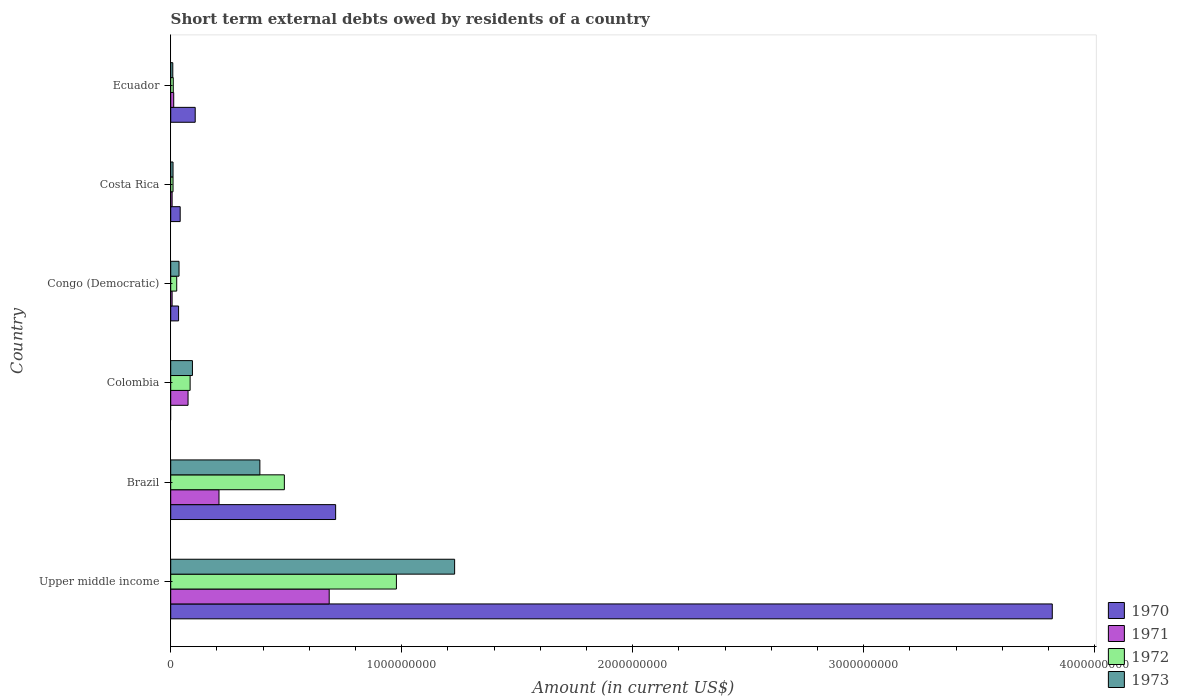How many different coloured bars are there?
Your answer should be very brief. 4. How many groups of bars are there?
Your response must be concise. 6. Are the number of bars on each tick of the Y-axis equal?
Your answer should be compact. No. How many bars are there on the 6th tick from the top?
Ensure brevity in your answer.  4. How many bars are there on the 1st tick from the bottom?
Your answer should be compact. 4. In how many cases, is the number of bars for a given country not equal to the number of legend labels?
Keep it short and to the point. 1. What is the amount of short-term external debts owed by residents in 1970 in Brazil?
Give a very brief answer. 7.14e+08. Across all countries, what is the maximum amount of short-term external debts owed by residents in 1972?
Give a very brief answer. 9.77e+08. In which country was the amount of short-term external debts owed by residents in 1972 maximum?
Make the answer very short. Upper middle income. What is the total amount of short-term external debts owed by residents in 1972 in the graph?
Make the answer very short. 1.60e+09. What is the difference between the amount of short-term external debts owed by residents in 1973 in Brazil and that in Ecuador?
Offer a very short reply. 3.77e+08. What is the difference between the amount of short-term external debts owed by residents in 1972 in Congo (Democratic) and the amount of short-term external debts owed by residents in 1971 in Brazil?
Offer a terse response. -1.83e+08. What is the average amount of short-term external debts owed by residents in 1970 per country?
Provide a short and direct response. 7.85e+08. What is the difference between the amount of short-term external debts owed by residents in 1970 and amount of short-term external debts owed by residents in 1971 in Brazil?
Your answer should be very brief. 5.05e+08. In how many countries, is the amount of short-term external debts owed by residents in 1972 greater than 1800000000 US$?
Give a very brief answer. 0. What is the ratio of the amount of short-term external debts owed by residents in 1972 in Brazil to that in Colombia?
Your response must be concise. 5.86. Is the difference between the amount of short-term external debts owed by residents in 1970 in Brazil and Upper middle income greater than the difference between the amount of short-term external debts owed by residents in 1971 in Brazil and Upper middle income?
Your answer should be very brief. No. What is the difference between the highest and the second highest amount of short-term external debts owed by residents in 1973?
Offer a very short reply. 8.43e+08. What is the difference between the highest and the lowest amount of short-term external debts owed by residents in 1973?
Offer a very short reply. 1.22e+09. Is the sum of the amount of short-term external debts owed by residents in 1973 in Congo (Democratic) and Costa Rica greater than the maximum amount of short-term external debts owed by residents in 1971 across all countries?
Provide a short and direct response. No. Are all the bars in the graph horizontal?
Provide a short and direct response. Yes. How many countries are there in the graph?
Offer a terse response. 6. What is the difference between two consecutive major ticks on the X-axis?
Offer a very short reply. 1.00e+09. Does the graph contain grids?
Offer a terse response. No. Where does the legend appear in the graph?
Provide a short and direct response. Bottom right. What is the title of the graph?
Offer a terse response. Short term external debts owed by residents of a country. What is the label or title of the X-axis?
Give a very brief answer. Amount (in current US$). What is the Amount (in current US$) of 1970 in Upper middle income?
Offer a very short reply. 3.82e+09. What is the Amount (in current US$) in 1971 in Upper middle income?
Your answer should be very brief. 6.86e+08. What is the Amount (in current US$) of 1972 in Upper middle income?
Make the answer very short. 9.77e+08. What is the Amount (in current US$) of 1973 in Upper middle income?
Provide a succinct answer. 1.23e+09. What is the Amount (in current US$) of 1970 in Brazil?
Your answer should be very brief. 7.14e+08. What is the Amount (in current US$) of 1971 in Brazil?
Provide a short and direct response. 2.09e+08. What is the Amount (in current US$) in 1972 in Brazil?
Keep it short and to the point. 4.92e+08. What is the Amount (in current US$) in 1973 in Brazil?
Provide a succinct answer. 3.86e+08. What is the Amount (in current US$) of 1971 in Colombia?
Your answer should be very brief. 7.50e+07. What is the Amount (in current US$) in 1972 in Colombia?
Make the answer very short. 8.40e+07. What is the Amount (in current US$) in 1973 in Colombia?
Your response must be concise. 9.40e+07. What is the Amount (in current US$) in 1970 in Congo (Democratic)?
Provide a short and direct response. 3.40e+07. What is the Amount (in current US$) in 1971 in Congo (Democratic)?
Provide a succinct answer. 6.00e+06. What is the Amount (in current US$) of 1972 in Congo (Democratic)?
Make the answer very short. 2.60e+07. What is the Amount (in current US$) in 1973 in Congo (Democratic)?
Provide a short and direct response. 3.60e+07. What is the Amount (in current US$) in 1970 in Costa Rica?
Offer a terse response. 4.10e+07. What is the Amount (in current US$) of 1971 in Costa Rica?
Ensure brevity in your answer.  6.00e+06. What is the Amount (in current US$) of 1973 in Costa Rica?
Ensure brevity in your answer.  1.00e+07. What is the Amount (in current US$) in 1970 in Ecuador?
Provide a succinct answer. 1.06e+08. What is the Amount (in current US$) in 1971 in Ecuador?
Provide a short and direct response. 1.30e+07. What is the Amount (in current US$) of 1972 in Ecuador?
Give a very brief answer. 1.10e+07. What is the Amount (in current US$) in 1973 in Ecuador?
Ensure brevity in your answer.  9.00e+06. Across all countries, what is the maximum Amount (in current US$) in 1970?
Offer a terse response. 3.82e+09. Across all countries, what is the maximum Amount (in current US$) of 1971?
Offer a terse response. 6.86e+08. Across all countries, what is the maximum Amount (in current US$) in 1972?
Provide a succinct answer. 9.77e+08. Across all countries, what is the maximum Amount (in current US$) of 1973?
Ensure brevity in your answer.  1.23e+09. Across all countries, what is the minimum Amount (in current US$) of 1970?
Offer a very short reply. 0. Across all countries, what is the minimum Amount (in current US$) in 1973?
Keep it short and to the point. 9.00e+06. What is the total Amount (in current US$) in 1970 in the graph?
Ensure brevity in your answer.  4.71e+09. What is the total Amount (in current US$) of 1971 in the graph?
Provide a succinct answer. 9.95e+08. What is the total Amount (in current US$) in 1972 in the graph?
Make the answer very short. 1.60e+09. What is the total Amount (in current US$) in 1973 in the graph?
Give a very brief answer. 1.76e+09. What is the difference between the Amount (in current US$) of 1970 in Upper middle income and that in Brazil?
Your answer should be very brief. 3.10e+09. What is the difference between the Amount (in current US$) of 1971 in Upper middle income and that in Brazil?
Give a very brief answer. 4.77e+08. What is the difference between the Amount (in current US$) in 1972 in Upper middle income and that in Brazil?
Make the answer very short. 4.85e+08. What is the difference between the Amount (in current US$) of 1973 in Upper middle income and that in Brazil?
Provide a succinct answer. 8.43e+08. What is the difference between the Amount (in current US$) in 1971 in Upper middle income and that in Colombia?
Ensure brevity in your answer.  6.11e+08. What is the difference between the Amount (in current US$) of 1972 in Upper middle income and that in Colombia?
Make the answer very short. 8.93e+08. What is the difference between the Amount (in current US$) in 1973 in Upper middle income and that in Colombia?
Make the answer very short. 1.14e+09. What is the difference between the Amount (in current US$) of 1970 in Upper middle income and that in Congo (Democratic)?
Give a very brief answer. 3.78e+09. What is the difference between the Amount (in current US$) of 1971 in Upper middle income and that in Congo (Democratic)?
Give a very brief answer. 6.80e+08. What is the difference between the Amount (in current US$) in 1972 in Upper middle income and that in Congo (Democratic)?
Provide a succinct answer. 9.51e+08. What is the difference between the Amount (in current US$) of 1973 in Upper middle income and that in Congo (Democratic)?
Give a very brief answer. 1.19e+09. What is the difference between the Amount (in current US$) in 1970 in Upper middle income and that in Costa Rica?
Offer a very short reply. 3.78e+09. What is the difference between the Amount (in current US$) of 1971 in Upper middle income and that in Costa Rica?
Offer a terse response. 6.80e+08. What is the difference between the Amount (in current US$) in 1972 in Upper middle income and that in Costa Rica?
Ensure brevity in your answer.  9.67e+08. What is the difference between the Amount (in current US$) in 1973 in Upper middle income and that in Costa Rica?
Ensure brevity in your answer.  1.22e+09. What is the difference between the Amount (in current US$) in 1970 in Upper middle income and that in Ecuador?
Your answer should be very brief. 3.71e+09. What is the difference between the Amount (in current US$) of 1971 in Upper middle income and that in Ecuador?
Provide a short and direct response. 6.73e+08. What is the difference between the Amount (in current US$) of 1972 in Upper middle income and that in Ecuador?
Give a very brief answer. 9.66e+08. What is the difference between the Amount (in current US$) in 1973 in Upper middle income and that in Ecuador?
Keep it short and to the point. 1.22e+09. What is the difference between the Amount (in current US$) of 1971 in Brazil and that in Colombia?
Provide a short and direct response. 1.34e+08. What is the difference between the Amount (in current US$) in 1972 in Brazil and that in Colombia?
Your answer should be very brief. 4.08e+08. What is the difference between the Amount (in current US$) in 1973 in Brazil and that in Colombia?
Give a very brief answer. 2.92e+08. What is the difference between the Amount (in current US$) of 1970 in Brazil and that in Congo (Democratic)?
Keep it short and to the point. 6.80e+08. What is the difference between the Amount (in current US$) in 1971 in Brazil and that in Congo (Democratic)?
Give a very brief answer. 2.03e+08. What is the difference between the Amount (in current US$) in 1972 in Brazil and that in Congo (Democratic)?
Give a very brief answer. 4.66e+08. What is the difference between the Amount (in current US$) of 1973 in Brazil and that in Congo (Democratic)?
Give a very brief answer. 3.50e+08. What is the difference between the Amount (in current US$) in 1970 in Brazil and that in Costa Rica?
Your answer should be compact. 6.73e+08. What is the difference between the Amount (in current US$) in 1971 in Brazil and that in Costa Rica?
Your response must be concise. 2.03e+08. What is the difference between the Amount (in current US$) of 1972 in Brazil and that in Costa Rica?
Your answer should be compact. 4.82e+08. What is the difference between the Amount (in current US$) in 1973 in Brazil and that in Costa Rica?
Keep it short and to the point. 3.76e+08. What is the difference between the Amount (in current US$) in 1970 in Brazil and that in Ecuador?
Offer a terse response. 6.08e+08. What is the difference between the Amount (in current US$) in 1971 in Brazil and that in Ecuador?
Your answer should be compact. 1.96e+08. What is the difference between the Amount (in current US$) of 1972 in Brazil and that in Ecuador?
Offer a terse response. 4.81e+08. What is the difference between the Amount (in current US$) in 1973 in Brazil and that in Ecuador?
Provide a short and direct response. 3.77e+08. What is the difference between the Amount (in current US$) of 1971 in Colombia and that in Congo (Democratic)?
Provide a short and direct response. 6.90e+07. What is the difference between the Amount (in current US$) in 1972 in Colombia and that in Congo (Democratic)?
Your answer should be compact. 5.80e+07. What is the difference between the Amount (in current US$) of 1973 in Colombia and that in Congo (Democratic)?
Offer a very short reply. 5.80e+07. What is the difference between the Amount (in current US$) in 1971 in Colombia and that in Costa Rica?
Offer a terse response. 6.90e+07. What is the difference between the Amount (in current US$) in 1972 in Colombia and that in Costa Rica?
Ensure brevity in your answer.  7.40e+07. What is the difference between the Amount (in current US$) of 1973 in Colombia and that in Costa Rica?
Make the answer very short. 8.40e+07. What is the difference between the Amount (in current US$) of 1971 in Colombia and that in Ecuador?
Provide a short and direct response. 6.20e+07. What is the difference between the Amount (in current US$) of 1972 in Colombia and that in Ecuador?
Your answer should be very brief. 7.30e+07. What is the difference between the Amount (in current US$) in 1973 in Colombia and that in Ecuador?
Your answer should be very brief. 8.50e+07. What is the difference between the Amount (in current US$) in 1970 in Congo (Democratic) and that in Costa Rica?
Your answer should be compact. -7.00e+06. What is the difference between the Amount (in current US$) of 1972 in Congo (Democratic) and that in Costa Rica?
Offer a terse response. 1.60e+07. What is the difference between the Amount (in current US$) in 1973 in Congo (Democratic) and that in Costa Rica?
Provide a short and direct response. 2.60e+07. What is the difference between the Amount (in current US$) of 1970 in Congo (Democratic) and that in Ecuador?
Offer a very short reply. -7.20e+07. What is the difference between the Amount (in current US$) of 1971 in Congo (Democratic) and that in Ecuador?
Give a very brief answer. -7.00e+06. What is the difference between the Amount (in current US$) in 1972 in Congo (Democratic) and that in Ecuador?
Offer a terse response. 1.50e+07. What is the difference between the Amount (in current US$) of 1973 in Congo (Democratic) and that in Ecuador?
Your response must be concise. 2.70e+07. What is the difference between the Amount (in current US$) of 1970 in Costa Rica and that in Ecuador?
Provide a succinct answer. -6.50e+07. What is the difference between the Amount (in current US$) of 1971 in Costa Rica and that in Ecuador?
Give a very brief answer. -7.00e+06. What is the difference between the Amount (in current US$) of 1972 in Costa Rica and that in Ecuador?
Make the answer very short. -1.00e+06. What is the difference between the Amount (in current US$) in 1973 in Costa Rica and that in Ecuador?
Offer a terse response. 1.00e+06. What is the difference between the Amount (in current US$) in 1970 in Upper middle income and the Amount (in current US$) in 1971 in Brazil?
Make the answer very short. 3.61e+09. What is the difference between the Amount (in current US$) of 1970 in Upper middle income and the Amount (in current US$) of 1972 in Brazil?
Offer a terse response. 3.32e+09. What is the difference between the Amount (in current US$) of 1970 in Upper middle income and the Amount (in current US$) of 1973 in Brazil?
Ensure brevity in your answer.  3.43e+09. What is the difference between the Amount (in current US$) of 1971 in Upper middle income and the Amount (in current US$) of 1972 in Brazil?
Give a very brief answer. 1.94e+08. What is the difference between the Amount (in current US$) of 1971 in Upper middle income and the Amount (in current US$) of 1973 in Brazil?
Give a very brief answer. 3.00e+08. What is the difference between the Amount (in current US$) in 1972 in Upper middle income and the Amount (in current US$) in 1973 in Brazil?
Provide a succinct answer. 5.91e+08. What is the difference between the Amount (in current US$) in 1970 in Upper middle income and the Amount (in current US$) in 1971 in Colombia?
Provide a succinct answer. 3.74e+09. What is the difference between the Amount (in current US$) of 1970 in Upper middle income and the Amount (in current US$) of 1972 in Colombia?
Make the answer very short. 3.73e+09. What is the difference between the Amount (in current US$) in 1970 in Upper middle income and the Amount (in current US$) in 1973 in Colombia?
Keep it short and to the point. 3.72e+09. What is the difference between the Amount (in current US$) of 1971 in Upper middle income and the Amount (in current US$) of 1972 in Colombia?
Offer a terse response. 6.02e+08. What is the difference between the Amount (in current US$) in 1971 in Upper middle income and the Amount (in current US$) in 1973 in Colombia?
Make the answer very short. 5.92e+08. What is the difference between the Amount (in current US$) of 1972 in Upper middle income and the Amount (in current US$) of 1973 in Colombia?
Provide a short and direct response. 8.83e+08. What is the difference between the Amount (in current US$) of 1970 in Upper middle income and the Amount (in current US$) of 1971 in Congo (Democratic)?
Give a very brief answer. 3.81e+09. What is the difference between the Amount (in current US$) of 1970 in Upper middle income and the Amount (in current US$) of 1972 in Congo (Democratic)?
Keep it short and to the point. 3.79e+09. What is the difference between the Amount (in current US$) of 1970 in Upper middle income and the Amount (in current US$) of 1973 in Congo (Democratic)?
Offer a terse response. 3.78e+09. What is the difference between the Amount (in current US$) in 1971 in Upper middle income and the Amount (in current US$) in 1972 in Congo (Democratic)?
Provide a succinct answer. 6.60e+08. What is the difference between the Amount (in current US$) in 1971 in Upper middle income and the Amount (in current US$) in 1973 in Congo (Democratic)?
Your answer should be compact. 6.50e+08. What is the difference between the Amount (in current US$) of 1972 in Upper middle income and the Amount (in current US$) of 1973 in Congo (Democratic)?
Your response must be concise. 9.41e+08. What is the difference between the Amount (in current US$) in 1970 in Upper middle income and the Amount (in current US$) in 1971 in Costa Rica?
Keep it short and to the point. 3.81e+09. What is the difference between the Amount (in current US$) of 1970 in Upper middle income and the Amount (in current US$) of 1972 in Costa Rica?
Offer a very short reply. 3.81e+09. What is the difference between the Amount (in current US$) in 1970 in Upper middle income and the Amount (in current US$) in 1973 in Costa Rica?
Make the answer very short. 3.81e+09. What is the difference between the Amount (in current US$) in 1971 in Upper middle income and the Amount (in current US$) in 1972 in Costa Rica?
Keep it short and to the point. 6.76e+08. What is the difference between the Amount (in current US$) of 1971 in Upper middle income and the Amount (in current US$) of 1973 in Costa Rica?
Your answer should be very brief. 6.76e+08. What is the difference between the Amount (in current US$) in 1972 in Upper middle income and the Amount (in current US$) in 1973 in Costa Rica?
Make the answer very short. 9.67e+08. What is the difference between the Amount (in current US$) of 1970 in Upper middle income and the Amount (in current US$) of 1971 in Ecuador?
Keep it short and to the point. 3.80e+09. What is the difference between the Amount (in current US$) of 1970 in Upper middle income and the Amount (in current US$) of 1972 in Ecuador?
Make the answer very short. 3.81e+09. What is the difference between the Amount (in current US$) of 1970 in Upper middle income and the Amount (in current US$) of 1973 in Ecuador?
Provide a succinct answer. 3.81e+09. What is the difference between the Amount (in current US$) of 1971 in Upper middle income and the Amount (in current US$) of 1972 in Ecuador?
Keep it short and to the point. 6.75e+08. What is the difference between the Amount (in current US$) in 1971 in Upper middle income and the Amount (in current US$) in 1973 in Ecuador?
Your response must be concise. 6.77e+08. What is the difference between the Amount (in current US$) in 1972 in Upper middle income and the Amount (in current US$) in 1973 in Ecuador?
Offer a very short reply. 9.68e+08. What is the difference between the Amount (in current US$) in 1970 in Brazil and the Amount (in current US$) in 1971 in Colombia?
Provide a short and direct response. 6.39e+08. What is the difference between the Amount (in current US$) in 1970 in Brazil and the Amount (in current US$) in 1972 in Colombia?
Provide a short and direct response. 6.30e+08. What is the difference between the Amount (in current US$) in 1970 in Brazil and the Amount (in current US$) in 1973 in Colombia?
Keep it short and to the point. 6.20e+08. What is the difference between the Amount (in current US$) in 1971 in Brazil and the Amount (in current US$) in 1972 in Colombia?
Your answer should be very brief. 1.25e+08. What is the difference between the Amount (in current US$) of 1971 in Brazil and the Amount (in current US$) of 1973 in Colombia?
Ensure brevity in your answer.  1.15e+08. What is the difference between the Amount (in current US$) in 1972 in Brazil and the Amount (in current US$) in 1973 in Colombia?
Make the answer very short. 3.98e+08. What is the difference between the Amount (in current US$) in 1970 in Brazil and the Amount (in current US$) in 1971 in Congo (Democratic)?
Give a very brief answer. 7.08e+08. What is the difference between the Amount (in current US$) of 1970 in Brazil and the Amount (in current US$) of 1972 in Congo (Democratic)?
Offer a terse response. 6.88e+08. What is the difference between the Amount (in current US$) of 1970 in Brazil and the Amount (in current US$) of 1973 in Congo (Democratic)?
Make the answer very short. 6.78e+08. What is the difference between the Amount (in current US$) of 1971 in Brazil and the Amount (in current US$) of 1972 in Congo (Democratic)?
Offer a terse response. 1.83e+08. What is the difference between the Amount (in current US$) in 1971 in Brazil and the Amount (in current US$) in 1973 in Congo (Democratic)?
Make the answer very short. 1.73e+08. What is the difference between the Amount (in current US$) of 1972 in Brazil and the Amount (in current US$) of 1973 in Congo (Democratic)?
Your answer should be compact. 4.56e+08. What is the difference between the Amount (in current US$) of 1970 in Brazil and the Amount (in current US$) of 1971 in Costa Rica?
Offer a very short reply. 7.08e+08. What is the difference between the Amount (in current US$) of 1970 in Brazil and the Amount (in current US$) of 1972 in Costa Rica?
Provide a succinct answer. 7.04e+08. What is the difference between the Amount (in current US$) of 1970 in Brazil and the Amount (in current US$) of 1973 in Costa Rica?
Provide a short and direct response. 7.04e+08. What is the difference between the Amount (in current US$) in 1971 in Brazil and the Amount (in current US$) in 1972 in Costa Rica?
Your answer should be very brief. 1.99e+08. What is the difference between the Amount (in current US$) in 1971 in Brazil and the Amount (in current US$) in 1973 in Costa Rica?
Your response must be concise. 1.99e+08. What is the difference between the Amount (in current US$) in 1972 in Brazil and the Amount (in current US$) in 1973 in Costa Rica?
Provide a succinct answer. 4.82e+08. What is the difference between the Amount (in current US$) of 1970 in Brazil and the Amount (in current US$) of 1971 in Ecuador?
Provide a short and direct response. 7.01e+08. What is the difference between the Amount (in current US$) in 1970 in Brazil and the Amount (in current US$) in 1972 in Ecuador?
Give a very brief answer. 7.03e+08. What is the difference between the Amount (in current US$) in 1970 in Brazil and the Amount (in current US$) in 1973 in Ecuador?
Keep it short and to the point. 7.05e+08. What is the difference between the Amount (in current US$) of 1971 in Brazil and the Amount (in current US$) of 1972 in Ecuador?
Keep it short and to the point. 1.98e+08. What is the difference between the Amount (in current US$) of 1971 in Brazil and the Amount (in current US$) of 1973 in Ecuador?
Provide a short and direct response. 2.00e+08. What is the difference between the Amount (in current US$) of 1972 in Brazil and the Amount (in current US$) of 1973 in Ecuador?
Ensure brevity in your answer.  4.83e+08. What is the difference between the Amount (in current US$) in 1971 in Colombia and the Amount (in current US$) in 1972 in Congo (Democratic)?
Your answer should be very brief. 4.90e+07. What is the difference between the Amount (in current US$) in 1971 in Colombia and the Amount (in current US$) in 1973 in Congo (Democratic)?
Your response must be concise. 3.90e+07. What is the difference between the Amount (in current US$) of 1972 in Colombia and the Amount (in current US$) of 1973 in Congo (Democratic)?
Make the answer very short. 4.80e+07. What is the difference between the Amount (in current US$) of 1971 in Colombia and the Amount (in current US$) of 1972 in Costa Rica?
Your response must be concise. 6.50e+07. What is the difference between the Amount (in current US$) of 1971 in Colombia and the Amount (in current US$) of 1973 in Costa Rica?
Make the answer very short. 6.50e+07. What is the difference between the Amount (in current US$) of 1972 in Colombia and the Amount (in current US$) of 1973 in Costa Rica?
Make the answer very short. 7.40e+07. What is the difference between the Amount (in current US$) of 1971 in Colombia and the Amount (in current US$) of 1972 in Ecuador?
Keep it short and to the point. 6.40e+07. What is the difference between the Amount (in current US$) in 1971 in Colombia and the Amount (in current US$) in 1973 in Ecuador?
Your answer should be very brief. 6.60e+07. What is the difference between the Amount (in current US$) in 1972 in Colombia and the Amount (in current US$) in 1973 in Ecuador?
Your answer should be very brief. 7.50e+07. What is the difference between the Amount (in current US$) of 1970 in Congo (Democratic) and the Amount (in current US$) of 1971 in Costa Rica?
Your answer should be compact. 2.80e+07. What is the difference between the Amount (in current US$) in 1970 in Congo (Democratic) and the Amount (in current US$) in 1972 in Costa Rica?
Keep it short and to the point. 2.40e+07. What is the difference between the Amount (in current US$) of 1970 in Congo (Democratic) and the Amount (in current US$) of 1973 in Costa Rica?
Offer a terse response. 2.40e+07. What is the difference between the Amount (in current US$) of 1972 in Congo (Democratic) and the Amount (in current US$) of 1973 in Costa Rica?
Keep it short and to the point. 1.60e+07. What is the difference between the Amount (in current US$) in 1970 in Congo (Democratic) and the Amount (in current US$) in 1971 in Ecuador?
Offer a very short reply. 2.10e+07. What is the difference between the Amount (in current US$) in 1970 in Congo (Democratic) and the Amount (in current US$) in 1972 in Ecuador?
Keep it short and to the point. 2.30e+07. What is the difference between the Amount (in current US$) of 1970 in Congo (Democratic) and the Amount (in current US$) of 1973 in Ecuador?
Provide a short and direct response. 2.50e+07. What is the difference between the Amount (in current US$) of 1971 in Congo (Democratic) and the Amount (in current US$) of 1972 in Ecuador?
Your response must be concise. -5.00e+06. What is the difference between the Amount (in current US$) of 1971 in Congo (Democratic) and the Amount (in current US$) of 1973 in Ecuador?
Offer a very short reply. -3.00e+06. What is the difference between the Amount (in current US$) in 1972 in Congo (Democratic) and the Amount (in current US$) in 1973 in Ecuador?
Provide a succinct answer. 1.70e+07. What is the difference between the Amount (in current US$) in 1970 in Costa Rica and the Amount (in current US$) in 1971 in Ecuador?
Provide a succinct answer. 2.80e+07. What is the difference between the Amount (in current US$) in 1970 in Costa Rica and the Amount (in current US$) in 1972 in Ecuador?
Keep it short and to the point. 3.00e+07. What is the difference between the Amount (in current US$) in 1970 in Costa Rica and the Amount (in current US$) in 1973 in Ecuador?
Offer a terse response. 3.20e+07. What is the difference between the Amount (in current US$) of 1971 in Costa Rica and the Amount (in current US$) of 1972 in Ecuador?
Your answer should be very brief. -5.00e+06. What is the difference between the Amount (in current US$) of 1971 in Costa Rica and the Amount (in current US$) of 1973 in Ecuador?
Give a very brief answer. -3.00e+06. What is the average Amount (in current US$) in 1970 per country?
Offer a terse response. 7.85e+08. What is the average Amount (in current US$) in 1971 per country?
Provide a succinct answer. 1.66e+08. What is the average Amount (in current US$) of 1972 per country?
Offer a terse response. 2.67e+08. What is the average Amount (in current US$) in 1973 per country?
Your answer should be compact. 2.94e+08. What is the difference between the Amount (in current US$) of 1970 and Amount (in current US$) of 1971 in Upper middle income?
Keep it short and to the point. 3.13e+09. What is the difference between the Amount (in current US$) in 1970 and Amount (in current US$) in 1972 in Upper middle income?
Ensure brevity in your answer.  2.84e+09. What is the difference between the Amount (in current US$) in 1970 and Amount (in current US$) in 1973 in Upper middle income?
Provide a short and direct response. 2.59e+09. What is the difference between the Amount (in current US$) in 1971 and Amount (in current US$) in 1972 in Upper middle income?
Your answer should be very brief. -2.91e+08. What is the difference between the Amount (in current US$) in 1971 and Amount (in current US$) in 1973 in Upper middle income?
Your answer should be compact. -5.43e+08. What is the difference between the Amount (in current US$) of 1972 and Amount (in current US$) of 1973 in Upper middle income?
Offer a terse response. -2.52e+08. What is the difference between the Amount (in current US$) in 1970 and Amount (in current US$) in 1971 in Brazil?
Provide a succinct answer. 5.05e+08. What is the difference between the Amount (in current US$) of 1970 and Amount (in current US$) of 1972 in Brazil?
Your response must be concise. 2.22e+08. What is the difference between the Amount (in current US$) in 1970 and Amount (in current US$) in 1973 in Brazil?
Your answer should be very brief. 3.28e+08. What is the difference between the Amount (in current US$) in 1971 and Amount (in current US$) in 1972 in Brazil?
Keep it short and to the point. -2.83e+08. What is the difference between the Amount (in current US$) in 1971 and Amount (in current US$) in 1973 in Brazil?
Your answer should be very brief. -1.77e+08. What is the difference between the Amount (in current US$) of 1972 and Amount (in current US$) of 1973 in Brazil?
Ensure brevity in your answer.  1.06e+08. What is the difference between the Amount (in current US$) of 1971 and Amount (in current US$) of 1972 in Colombia?
Provide a short and direct response. -9.00e+06. What is the difference between the Amount (in current US$) of 1971 and Amount (in current US$) of 1973 in Colombia?
Your answer should be very brief. -1.90e+07. What is the difference between the Amount (in current US$) of 1972 and Amount (in current US$) of 1973 in Colombia?
Your answer should be compact. -1.00e+07. What is the difference between the Amount (in current US$) of 1970 and Amount (in current US$) of 1971 in Congo (Democratic)?
Offer a terse response. 2.80e+07. What is the difference between the Amount (in current US$) of 1971 and Amount (in current US$) of 1972 in Congo (Democratic)?
Give a very brief answer. -2.00e+07. What is the difference between the Amount (in current US$) in 1971 and Amount (in current US$) in 1973 in Congo (Democratic)?
Provide a succinct answer. -3.00e+07. What is the difference between the Amount (in current US$) of 1972 and Amount (in current US$) of 1973 in Congo (Democratic)?
Your answer should be very brief. -1.00e+07. What is the difference between the Amount (in current US$) in 1970 and Amount (in current US$) in 1971 in Costa Rica?
Keep it short and to the point. 3.50e+07. What is the difference between the Amount (in current US$) in 1970 and Amount (in current US$) in 1972 in Costa Rica?
Keep it short and to the point. 3.10e+07. What is the difference between the Amount (in current US$) of 1970 and Amount (in current US$) of 1973 in Costa Rica?
Offer a very short reply. 3.10e+07. What is the difference between the Amount (in current US$) in 1971 and Amount (in current US$) in 1972 in Costa Rica?
Your response must be concise. -4.00e+06. What is the difference between the Amount (in current US$) of 1971 and Amount (in current US$) of 1973 in Costa Rica?
Make the answer very short. -4.00e+06. What is the difference between the Amount (in current US$) in 1970 and Amount (in current US$) in 1971 in Ecuador?
Give a very brief answer. 9.30e+07. What is the difference between the Amount (in current US$) in 1970 and Amount (in current US$) in 1972 in Ecuador?
Provide a short and direct response. 9.50e+07. What is the difference between the Amount (in current US$) in 1970 and Amount (in current US$) in 1973 in Ecuador?
Provide a short and direct response. 9.70e+07. What is the difference between the Amount (in current US$) of 1971 and Amount (in current US$) of 1973 in Ecuador?
Make the answer very short. 4.00e+06. What is the difference between the Amount (in current US$) in 1972 and Amount (in current US$) in 1973 in Ecuador?
Your answer should be very brief. 2.00e+06. What is the ratio of the Amount (in current US$) in 1970 in Upper middle income to that in Brazil?
Offer a very short reply. 5.35. What is the ratio of the Amount (in current US$) of 1971 in Upper middle income to that in Brazil?
Ensure brevity in your answer.  3.28. What is the ratio of the Amount (in current US$) of 1972 in Upper middle income to that in Brazil?
Provide a succinct answer. 1.99. What is the ratio of the Amount (in current US$) of 1973 in Upper middle income to that in Brazil?
Ensure brevity in your answer.  3.18. What is the ratio of the Amount (in current US$) of 1971 in Upper middle income to that in Colombia?
Your answer should be compact. 9.15. What is the ratio of the Amount (in current US$) of 1972 in Upper middle income to that in Colombia?
Ensure brevity in your answer.  11.63. What is the ratio of the Amount (in current US$) in 1973 in Upper middle income to that in Colombia?
Offer a very short reply. 13.08. What is the ratio of the Amount (in current US$) of 1970 in Upper middle income to that in Congo (Democratic)?
Offer a terse response. 112.25. What is the ratio of the Amount (in current US$) in 1971 in Upper middle income to that in Congo (Democratic)?
Ensure brevity in your answer.  114.35. What is the ratio of the Amount (in current US$) of 1972 in Upper middle income to that in Congo (Democratic)?
Keep it short and to the point. 37.58. What is the ratio of the Amount (in current US$) of 1973 in Upper middle income to that in Congo (Democratic)?
Your response must be concise. 34.14. What is the ratio of the Amount (in current US$) in 1970 in Upper middle income to that in Costa Rica?
Make the answer very short. 93.09. What is the ratio of the Amount (in current US$) of 1971 in Upper middle income to that in Costa Rica?
Make the answer very short. 114.35. What is the ratio of the Amount (in current US$) of 1972 in Upper middle income to that in Costa Rica?
Offer a very short reply. 97.71. What is the ratio of the Amount (in current US$) of 1973 in Upper middle income to that in Costa Rica?
Your answer should be very brief. 122.91. What is the ratio of the Amount (in current US$) in 1970 in Upper middle income to that in Ecuador?
Offer a very short reply. 36.01. What is the ratio of the Amount (in current US$) in 1971 in Upper middle income to that in Ecuador?
Your answer should be very brief. 52.78. What is the ratio of the Amount (in current US$) of 1972 in Upper middle income to that in Ecuador?
Provide a short and direct response. 88.83. What is the ratio of the Amount (in current US$) of 1973 in Upper middle income to that in Ecuador?
Offer a very short reply. 136.57. What is the ratio of the Amount (in current US$) of 1971 in Brazil to that in Colombia?
Your response must be concise. 2.79. What is the ratio of the Amount (in current US$) in 1972 in Brazil to that in Colombia?
Make the answer very short. 5.86. What is the ratio of the Amount (in current US$) of 1973 in Brazil to that in Colombia?
Provide a short and direct response. 4.11. What is the ratio of the Amount (in current US$) in 1970 in Brazil to that in Congo (Democratic)?
Your response must be concise. 21. What is the ratio of the Amount (in current US$) in 1971 in Brazil to that in Congo (Democratic)?
Your answer should be very brief. 34.83. What is the ratio of the Amount (in current US$) in 1972 in Brazil to that in Congo (Democratic)?
Give a very brief answer. 18.92. What is the ratio of the Amount (in current US$) of 1973 in Brazil to that in Congo (Democratic)?
Your answer should be compact. 10.72. What is the ratio of the Amount (in current US$) of 1970 in Brazil to that in Costa Rica?
Your response must be concise. 17.41. What is the ratio of the Amount (in current US$) of 1971 in Brazil to that in Costa Rica?
Make the answer very short. 34.83. What is the ratio of the Amount (in current US$) in 1972 in Brazil to that in Costa Rica?
Ensure brevity in your answer.  49.2. What is the ratio of the Amount (in current US$) of 1973 in Brazil to that in Costa Rica?
Ensure brevity in your answer.  38.6. What is the ratio of the Amount (in current US$) in 1970 in Brazil to that in Ecuador?
Your answer should be compact. 6.74. What is the ratio of the Amount (in current US$) in 1971 in Brazil to that in Ecuador?
Your response must be concise. 16.08. What is the ratio of the Amount (in current US$) in 1972 in Brazil to that in Ecuador?
Offer a very short reply. 44.73. What is the ratio of the Amount (in current US$) of 1973 in Brazil to that in Ecuador?
Your answer should be very brief. 42.89. What is the ratio of the Amount (in current US$) of 1971 in Colombia to that in Congo (Democratic)?
Your answer should be compact. 12.5. What is the ratio of the Amount (in current US$) in 1972 in Colombia to that in Congo (Democratic)?
Your answer should be very brief. 3.23. What is the ratio of the Amount (in current US$) of 1973 in Colombia to that in Congo (Democratic)?
Keep it short and to the point. 2.61. What is the ratio of the Amount (in current US$) in 1971 in Colombia to that in Costa Rica?
Make the answer very short. 12.5. What is the ratio of the Amount (in current US$) of 1971 in Colombia to that in Ecuador?
Your answer should be compact. 5.77. What is the ratio of the Amount (in current US$) of 1972 in Colombia to that in Ecuador?
Your answer should be compact. 7.64. What is the ratio of the Amount (in current US$) in 1973 in Colombia to that in Ecuador?
Offer a very short reply. 10.44. What is the ratio of the Amount (in current US$) of 1970 in Congo (Democratic) to that in Costa Rica?
Give a very brief answer. 0.83. What is the ratio of the Amount (in current US$) of 1971 in Congo (Democratic) to that in Costa Rica?
Your response must be concise. 1. What is the ratio of the Amount (in current US$) of 1973 in Congo (Democratic) to that in Costa Rica?
Provide a succinct answer. 3.6. What is the ratio of the Amount (in current US$) in 1970 in Congo (Democratic) to that in Ecuador?
Provide a succinct answer. 0.32. What is the ratio of the Amount (in current US$) in 1971 in Congo (Democratic) to that in Ecuador?
Offer a terse response. 0.46. What is the ratio of the Amount (in current US$) in 1972 in Congo (Democratic) to that in Ecuador?
Ensure brevity in your answer.  2.36. What is the ratio of the Amount (in current US$) in 1970 in Costa Rica to that in Ecuador?
Your answer should be very brief. 0.39. What is the ratio of the Amount (in current US$) of 1971 in Costa Rica to that in Ecuador?
Offer a terse response. 0.46. What is the ratio of the Amount (in current US$) in 1972 in Costa Rica to that in Ecuador?
Keep it short and to the point. 0.91. What is the difference between the highest and the second highest Amount (in current US$) of 1970?
Give a very brief answer. 3.10e+09. What is the difference between the highest and the second highest Amount (in current US$) of 1971?
Your response must be concise. 4.77e+08. What is the difference between the highest and the second highest Amount (in current US$) of 1972?
Offer a terse response. 4.85e+08. What is the difference between the highest and the second highest Amount (in current US$) of 1973?
Your response must be concise. 8.43e+08. What is the difference between the highest and the lowest Amount (in current US$) in 1970?
Your answer should be compact. 3.82e+09. What is the difference between the highest and the lowest Amount (in current US$) of 1971?
Make the answer very short. 6.80e+08. What is the difference between the highest and the lowest Amount (in current US$) of 1972?
Give a very brief answer. 9.67e+08. What is the difference between the highest and the lowest Amount (in current US$) of 1973?
Offer a very short reply. 1.22e+09. 